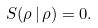<formula> <loc_0><loc_0><loc_500><loc_500>S ( \rho \, | \, \rho ) = 0 .</formula> 